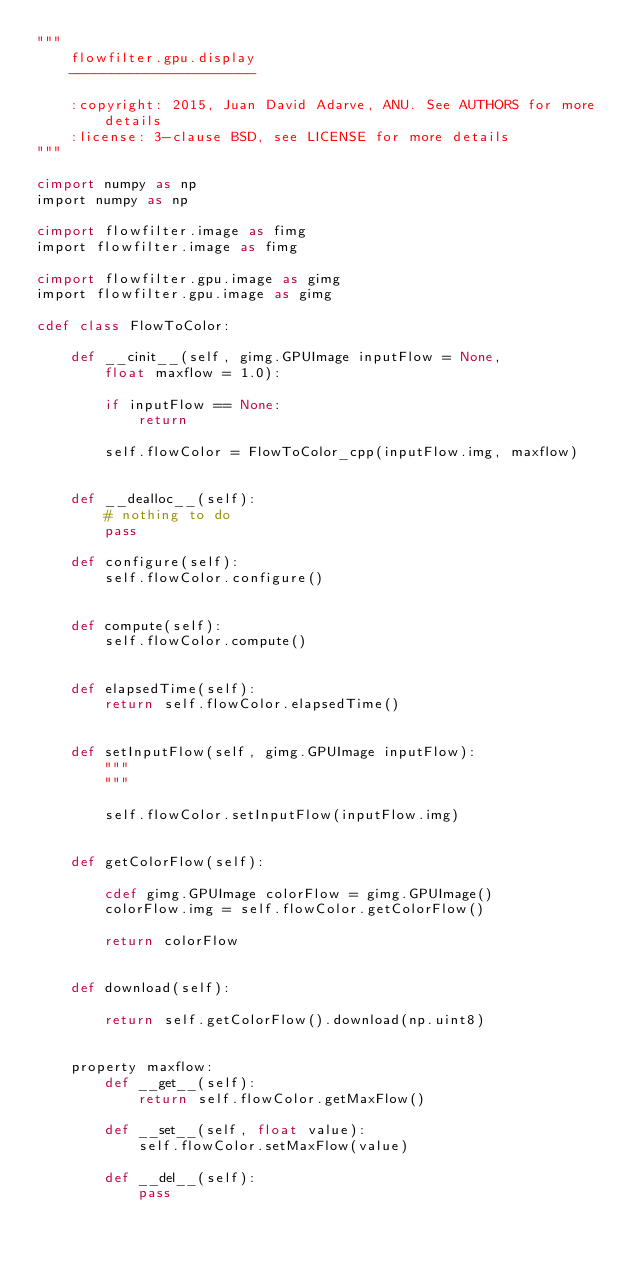Convert code to text. <code><loc_0><loc_0><loc_500><loc_500><_Cython_>"""
    flowfilter.gpu.display
    ----------------------

    :copyright: 2015, Juan David Adarve, ANU. See AUTHORS for more details
    :license: 3-clause BSD, see LICENSE for more details
"""

cimport numpy as np
import numpy as np

cimport flowfilter.image as fimg
import flowfilter.image as fimg

cimport flowfilter.gpu.image as gimg
import flowfilter.gpu.image as gimg

cdef class FlowToColor:
    
    def __cinit__(self, gimg.GPUImage inputFlow = None,
        float maxflow = 1.0):

        if inputFlow == None:
            return

        self.flowColor = FlowToColor_cpp(inputFlow.img, maxflow)


    def __dealloc__(self):
        # nothing to do
        pass

    def configure(self):
        self.flowColor.configure()


    def compute(self):
        self.flowColor.compute()


    def elapsedTime(self):
        return self.flowColor.elapsedTime()


    def setInputFlow(self, gimg.GPUImage inputFlow):
        """
        """

        self.flowColor.setInputFlow(inputFlow.img)


    def getColorFlow(self):

        cdef gimg.GPUImage colorFlow = gimg.GPUImage()
        colorFlow.img = self.flowColor.getColorFlow()

        return colorFlow


    def download(self):

        return self.getColorFlow().download(np.uint8)


    property maxflow:
        def __get__(self):
            return self.flowColor.getMaxFlow()

        def __set__(self, float value):
            self.flowColor.setMaxFlow(value)

        def __del__(self):
            pass</code> 